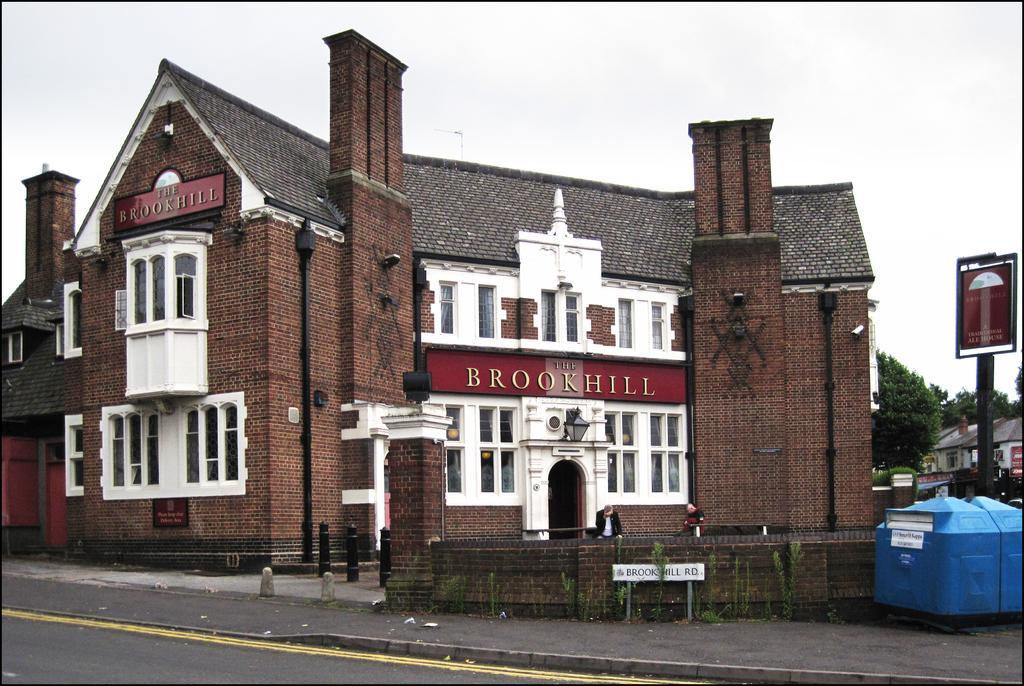Describe this image in one or two sentences. In the image we can see a building and these are the windows of the building. We can even see there are trees and here we can see a pole and a board. There are even people wearing clothes, here we can see a road, garbage bin, text and white sky. 